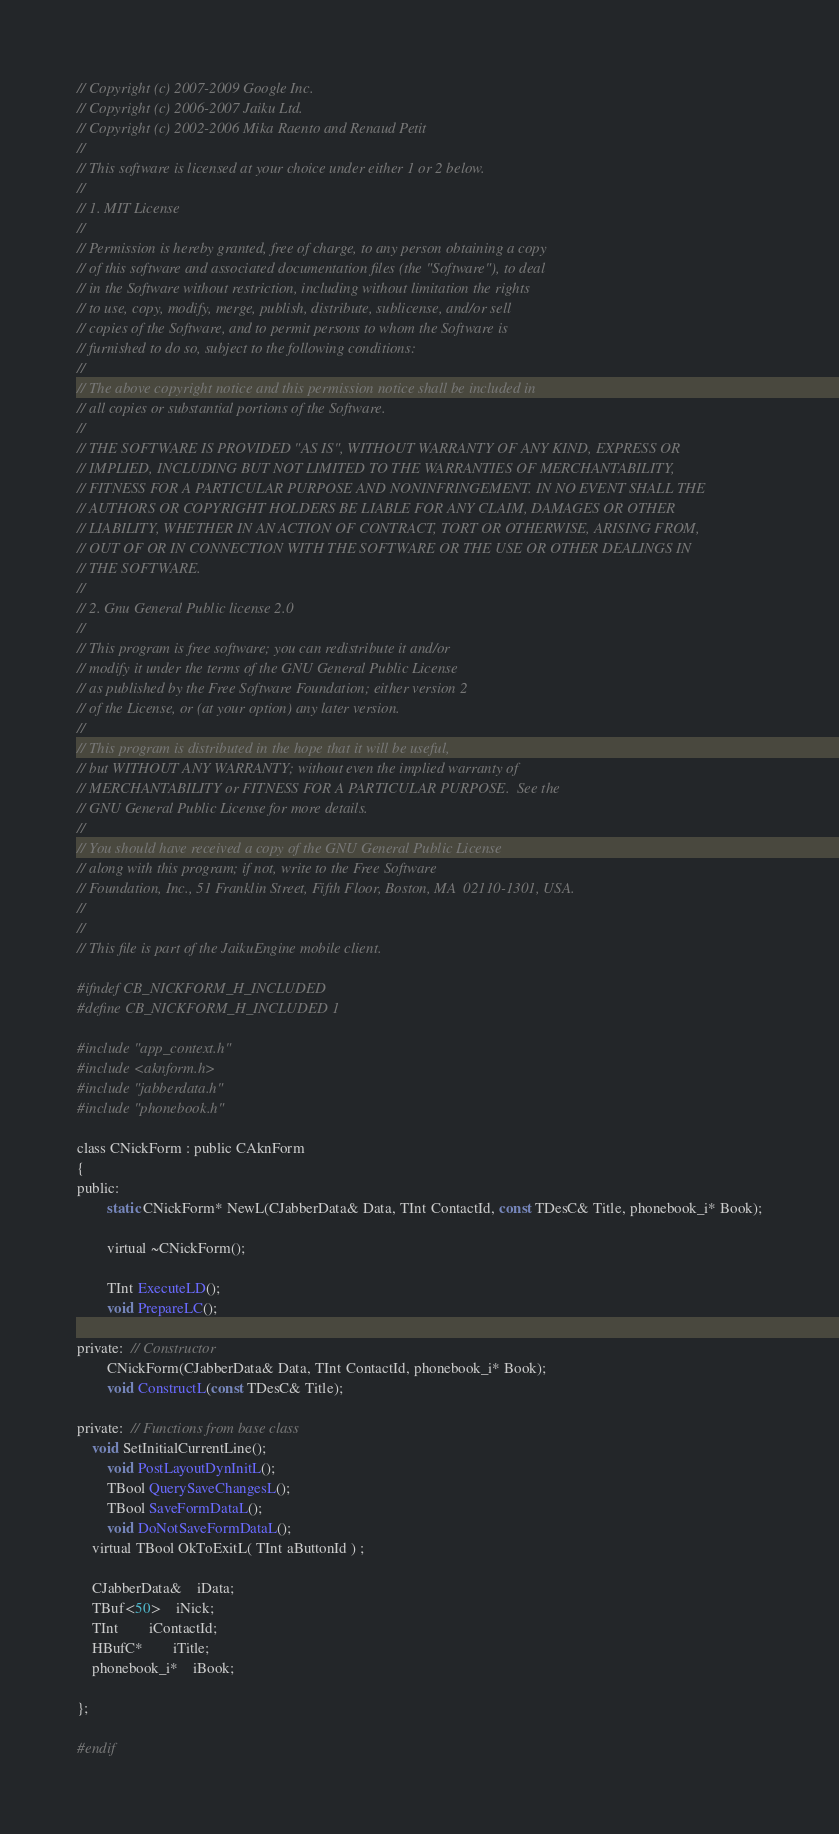Convert code to text. <code><loc_0><loc_0><loc_500><loc_500><_C_>// Copyright (c) 2007-2009 Google Inc.
// Copyright (c) 2006-2007 Jaiku Ltd.
// Copyright (c) 2002-2006 Mika Raento and Renaud Petit
//
// This software is licensed at your choice under either 1 or 2 below.
//
// 1. MIT License
//
// Permission is hereby granted, free of charge, to any person obtaining a copy
// of this software and associated documentation files (the "Software"), to deal
// in the Software without restriction, including without limitation the rights
// to use, copy, modify, merge, publish, distribute, sublicense, and/or sell
// copies of the Software, and to permit persons to whom the Software is
// furnished to do so, subject to the following conditions:
//
// The above copyright notice and this permission notice shall be included in
// all copies or substantial portions of the Software.
//
// THE SOFTWARE IS PROVIDED "AS IS", WITHOUT WARRANTY OF ANY KIND, EXPRESS OR
// IMPLIED, INCLUDING BUT NOT LIMITED TO THE WARRANTIES OF MERCHANTABILITY,
// FITNESS FOR A PARTICULAR PURPOSE AND NONINFRINGEMENT. IN NO EVENT SHALL THE
// AUTHORS OR COPYRIGHT HOLDERS BE LIABLE FOR ANY CLAIM, DAMAGES OR OTHER
// LIABILITY, WHETHER IN AN ACTION OF CONTRACT, TORT OR OTHERWISE, ARISING FROM,
// OUT OF OR IN CONNECTION WITH THE SOFTWARE OR THE USE OR OTHER DEALINGS IN
// THE SOFTWARE.
//
// 2. Gnu General Public license 2.0
//
// This program is free software; you can redistribute it and/or
// modify it under the terms of the GNU General Public License
// as published by the Free Software Foundation; either version 2
// of the License, or (at your option) any later version.
//
// This program is distributed in the hope that it will be useful,
// but WITHOUT ANY WARRANTY; without even the implied warranty of
// MERCHANTABILITY or FITNESS FOR A PARTICULAR PURPOSE.  See the
// GNU General Public License for more details.
//
// You should have received a copy of the GNU General Public License
// along with this program; if not, write to the Free Software
// Foundation, Inc., 51 Franklin Street, Fifth Floor, Boston, MA  02110-1301, USA.
//
//
// This file is part of the JaikuEngine mobile client.

#ifndef CB_NICKFORM_H_INCLUDED
#define CB_NICKFORM_H_INCLUDED 1

#include "app_context.h"
#include <aknform.h>
#include "jabberdata.h"
#include "phonebook.h"

class CNickForm : public CAknForm
{
public:
        static CNickForm* NewL(CJabberData& Data, TInt ContactId, const TDesC& Title, phonebook_i* Book);
	
        virtual ~CNickForm();
	
        TInt ExecuteLD(); 
        void PrepareLC(); 
	
private:  // Constructor
        CNickForm(CJabberData& Data, TInt ContactId, phonebook_i* Book);
        void ConstructL(const TDesC& Title);
	
private:  // Functions from base class
	void SetInitialCurrentLine();
        void PostLayoutDynInitL();
        TBool QuerySaveChangesL();
        TBool SaveFormDataL(); 
        void DoNotSaveFormDataL();
	virtual TBool OkToExitL( TInt aButtonId ) ;

	CJabberData&	iData;
	TBuf<50>	iNick;
	TInt		iContactId;
	HBufC*		iTitle;
	phonebook_i*	iBook;

};

#endif
</code> 